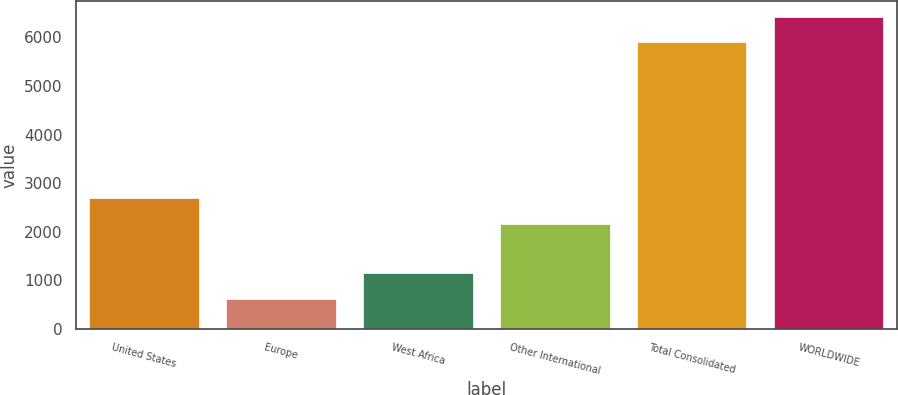Convert chart to OTSL. <chart><loc_0><loc_0><loc_500><loc_500><bar_chart><fcel>United States<fcel>Europe<fcel>West Africa<fcel>Other International<fcel>Total Consolidated<fcel>WORLDWIDE<nl><fcel>2689<fcel>623<fcel>1151<fcel>2161<fcel>5903<fcel>6431<nl></chart> 